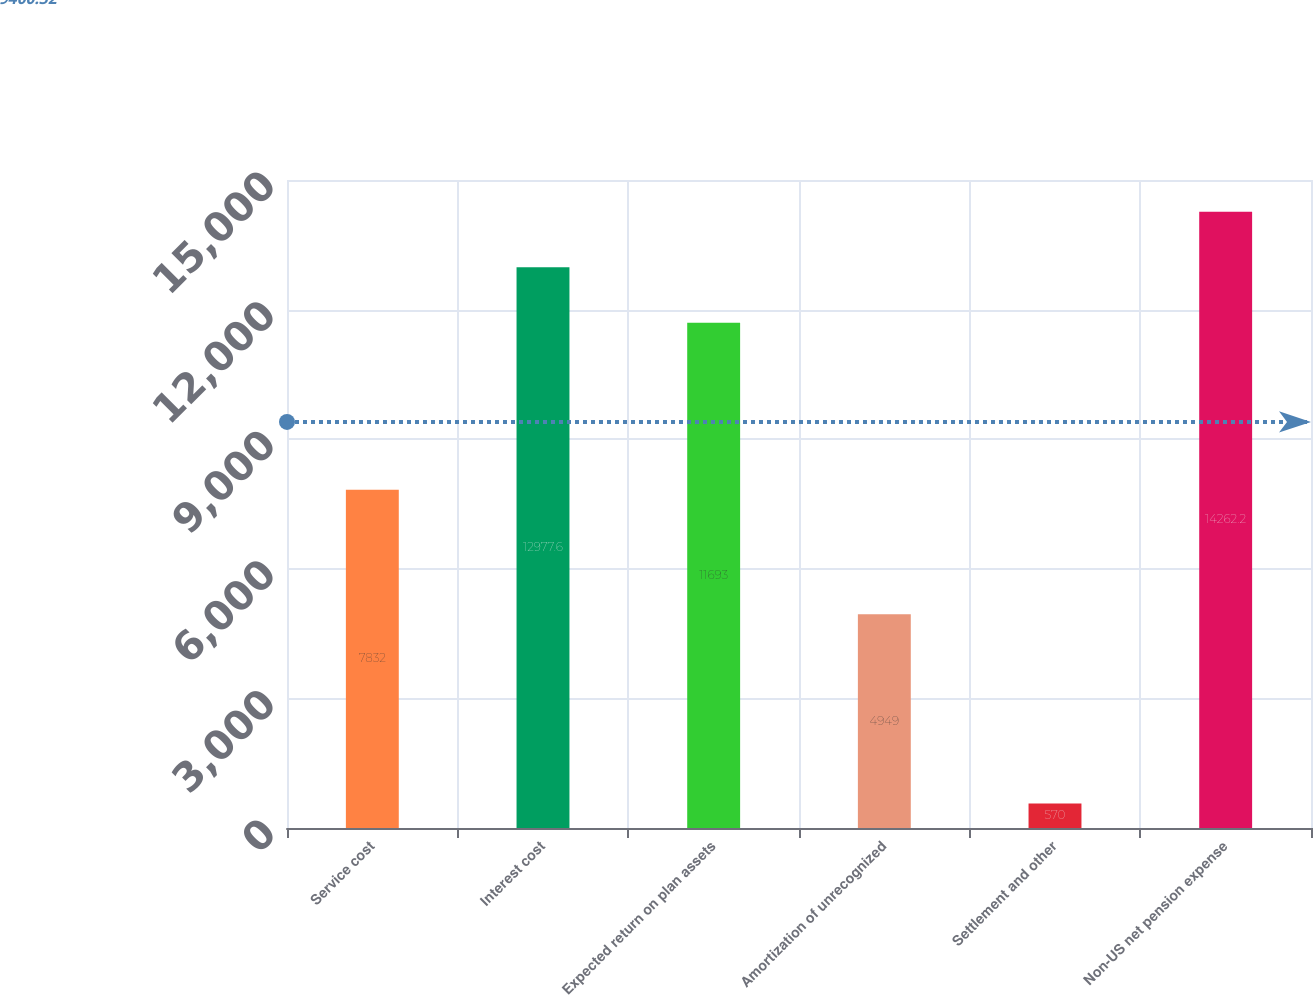Convert chart to OTSL. <chart><loc_0><loc_0><loc_500><loc_500><bar_chart><fcel>Service cost<fcel>Interest cost<fcel>Expected return on plan assets<fcel>Amortization of unrecognized<fcel>Settlement and other<fcel>Non-US net pension expense<nl><fcel>7832<fcel>12977.6<fcel>11693<fcel>4949<fcel>570<fcel>14262.2<nl></chart> 